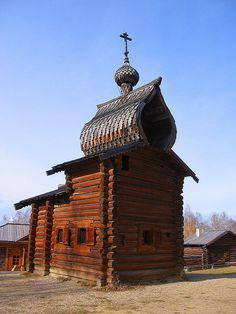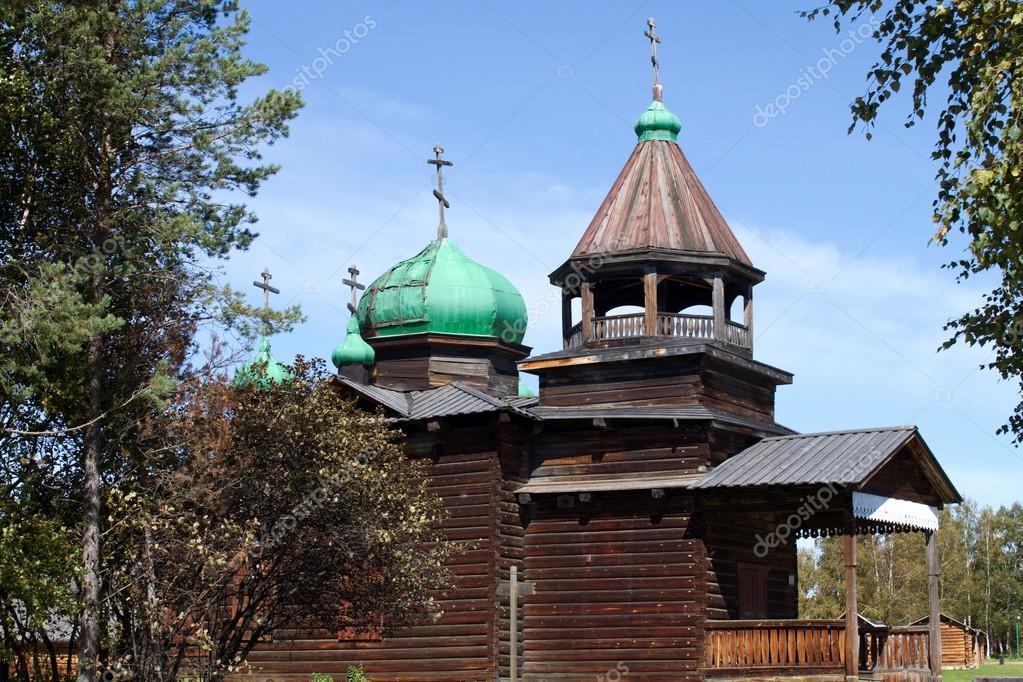The first image is the image on the left, the second image is the image on the right. Evaluate the accuracy of this statement regarding the images: "There is a cross atop the building in the image on the left.". Is it true? Answer yes or no. Yes. The first image is the image on the left, the second image is the image on the right. Assess this claim about the two images: "In one image, the roof features green shapes topped with crosses.". Correct or not? Answer yes or no. Yes. 